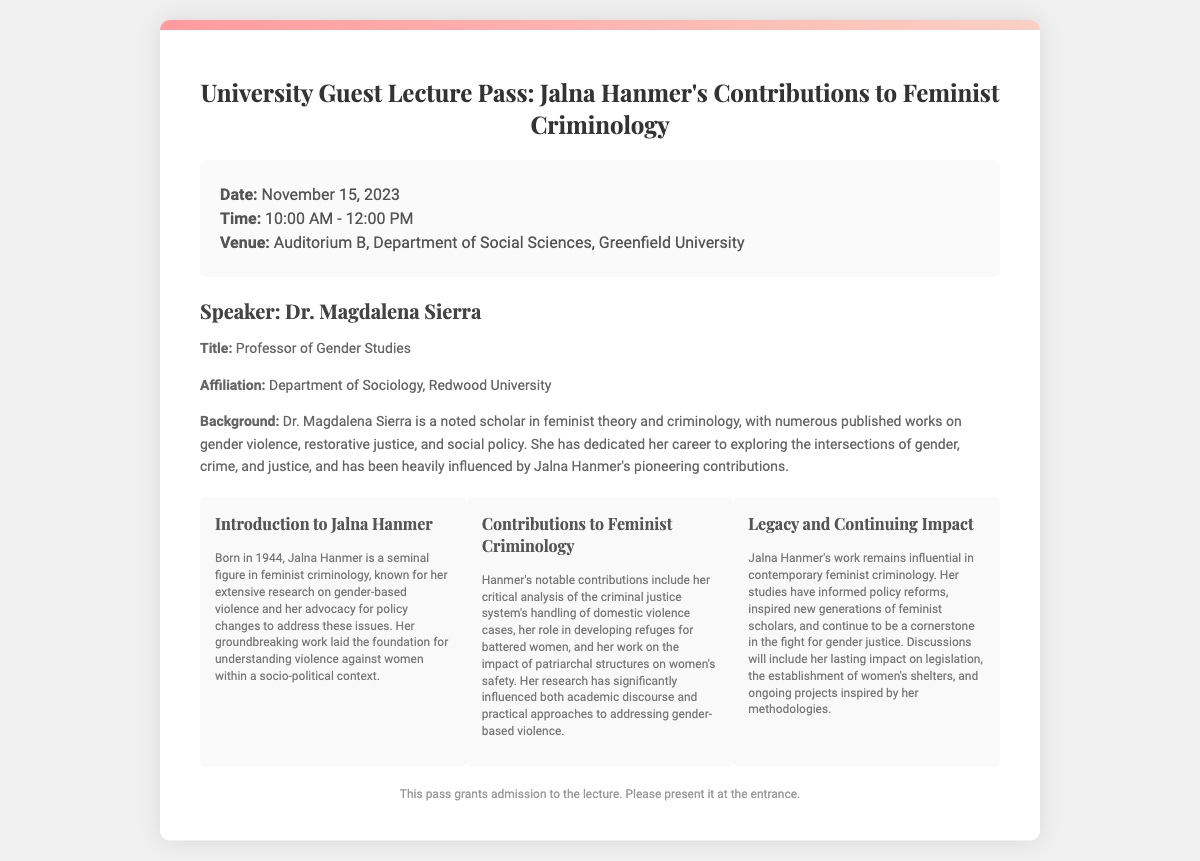What is the date of the lecture? The date of the lecture is specified in the document under the lecture details section.
Answer: November 15, 2023 Who is the speaker? The speaker's name is identified in the speaker bio section of the document.
Answer: Dr. Magdalena Sierra What venue will the lecture take place? The venue for the lecture is provided in the lecture details section of the document.
Answer: Auditorium B, Department of Social Sciences, Greenfield University What is Dr. Magdalena Sierra's title? Dr. Magdalena Sierra's title is stated in the speaker bio section of the document.
Answer: Professor of Gender Studies What is Jalna Hanmer known for? The document highlights Jalna Hanmer's significance in the context of feminist criminology and her research focus.
Answer: Gender-based violence What years did Jalna Hanmer live? The document provides specific information about Jalna Hanmer's birth year.
Answer: 1944 What influence has Jalna Hanmer had on contemporary feminist criminology? The document mentions her lasting influence on feminist criminology and related practices.
Answer: Significant What is the duration of the lecture? The duration is indicated in the lecture details section of the document by mentioning the start and end times.
Answer: 2 hours What institution is Dr. Magdalena Sierra affiliated with? The document specifies Dr. Magdalena Sierra's affiliation in the speaker bio section.
Answer: Redwood University 